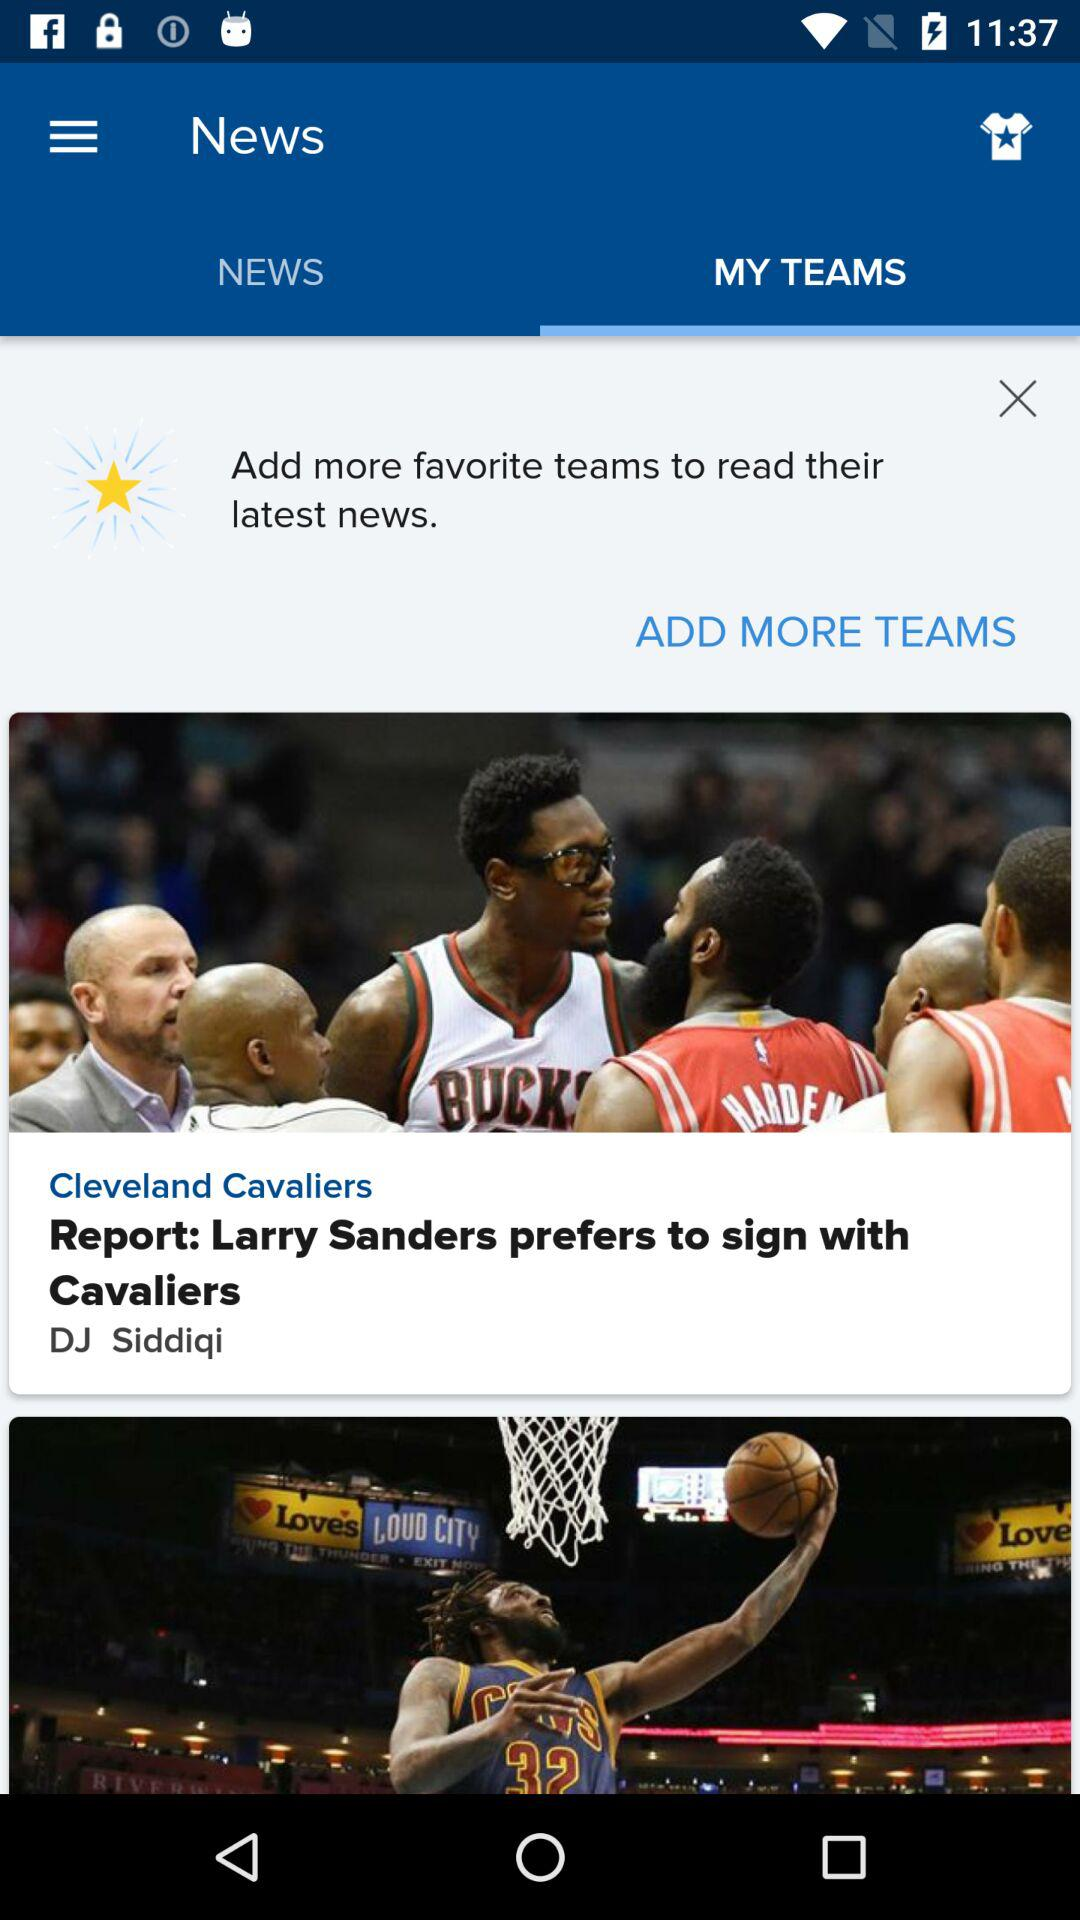Who is the author of the news "Larry Sanders prefers to sign with Cavaliers"? The author is "DJ Siddiqi". 